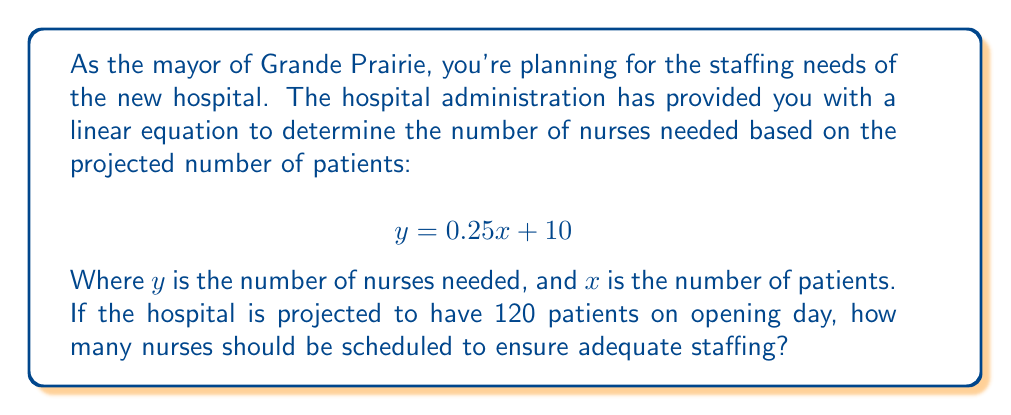Provide a solution to this math problem. To solve this problem, we need to use the given linear equation and substitute the known value for $x$ (number of patients).

Given:
- Linear equation: $y = 0.25x + 10$
- Number of patients ($x$) = 120

Step 1: Substitute $x = 120$ into the equation.
$$ y = 0.25(120) + 10 $$

Step 2: Calculate the value inside the parentheses.
$$ y = 30 + 10 $$

Step 3: Add the numbers to get the final result.
$$ y = 40 $$

Therefore, 40 nurses should be scheduled for the projected 120 patients on opening day.

Note: The equation suggests that there's a base staffing of 10 nurses regardless of patient count, and an additional nurse is needed for every 4 patients (0.25 nurses per patient).
Answer: 40 nurses 